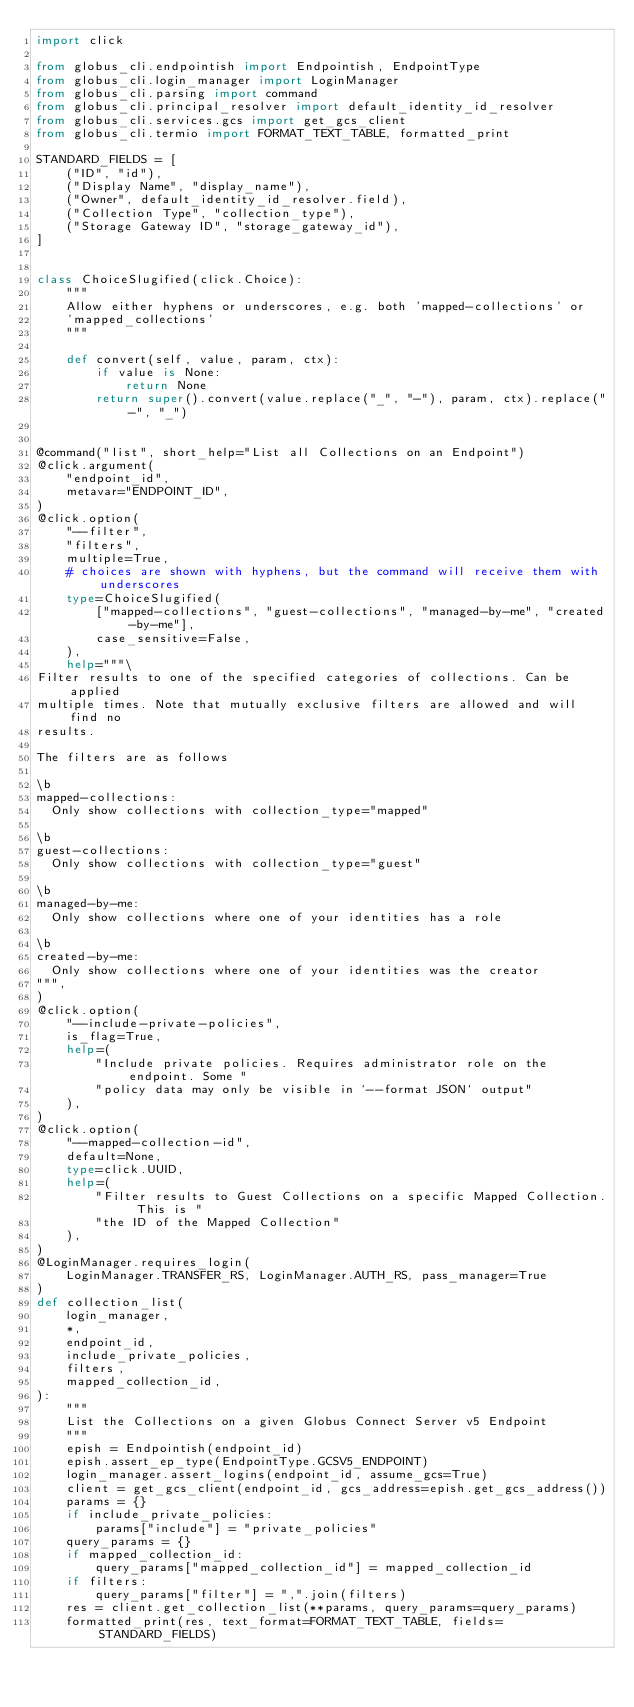<code> <loc_0><loc_0><loc_500><loc_500><_Python_>import click

from globus_cli.endpointish import Endpointish, EndpointType
from globus_cli.login_manager import LoginManager
from globus_cli.parsing import command
from globus_cli.principal_resolver import default_identity_id_resolver
from globus_cli.services.gcs import get_gcs_client
from globus_cli.termio import FORMAT_TEXT_TABLE, formatted_print

STANDARD_FIELDS = [
    ("ID", "id"),
    ("Display Name", "display_name"),
    ("Owner", default_identity_id_resolver.field),
    ("Collection Type", "collection_type"),
    ("Storage Gateway ID", "storage_gateway_id"),
]


class ChoiceSlugified(click.Choice):
    """
    Allow either hyphens or underscores, e.g. both 'mapped-collections' or
    'mapped_collections'
    """

    def convert(self, value, param, ctx):
        if value is None:
            return None
        return super().convert(value.replace("_", "-"), param, ctx).replace("-", "_")


@command("list", short_help="List all Collections on an Endpoint")
@click.argument(
    "endpoint_id",
    metavar="ENDPOINT_ID",
)
@click.option(
    "--filter",
    "filters",
    multiple=True,
    # choices are shown with hyphens, but the command will receive them with underscores
    type=ChoiceSlugified(
        ["mapped-collections", "guest-collections", "managed-by-me", "created-by-me"],
        case_sensitive=False,
    ),
    help="""\
Filter results to one of the specified categories of collections. Can be applied
multiple times. Note that mutually exclusive filters are allowed and will find no
results.

The filters are as follows

\b
mapped-collections:
  Only show collections with collection_type="mapped"

\b
guest-collections:
  Only show collections with collection_type="guest"

\b
managed-by-me:
  Only show collections where one of your identities has a role

\b
created-by-me:
  Only show collections where one of your identities was the creator
""",
)
@click.option(
    "--include-private-policies",
    is_flag=True,
    help=(
        "Include private policies. Requires administrator role on the endpoint. Some "
        "policy data may only be visible in `--format JSON` output"
    ),
)
@click.option(
    "--mapped-collection-id",
    default=None,
    type=click.UUID,
    help=(
        "Filter results to Guest Collections on a specific Mapped Collection. This is "
        "the ID of the Mapped Collection"
    ),
)
@LoginManager.requires_login(
    LoginManager.TRANSFER_RS, LoginManager.AUTH_RS, pass_manager=True
)
def collection_list(
    login_manager,
    *,
    endpoint_id,
    include_private_policies,
    filters,
    mapped_collection_id,
):
    """
    List the Collections on a given Globus Connect Server v5 Endpoint
    """
    epish = Endpointish(endpoint_id)
    epish.assert_ep_type(EndpointType.GCSV5_ENDPOINT)
    login_manager.assert_logins(endpoint_id, assume_gcs=True)
    client = get_gcs_client(endpoint_id, gcs_address=epish.get_gcs_address())
    params = {}
    if include_private_policies:
        params["include"] = "private_policies"
    query_params = {}
    if mapped_collection_id:
        query_params["mapped_collection_id"] = mapped_collection_id
    if filters:
        query_params["filter"] = ",".join(filters)
    res = client.get_collection_list(**params, query_params=query_params)
    formatted_print(res, text_format=FORMAT_TEXT_TABLE, fields=STANDARD_FIELDS)
</code> 